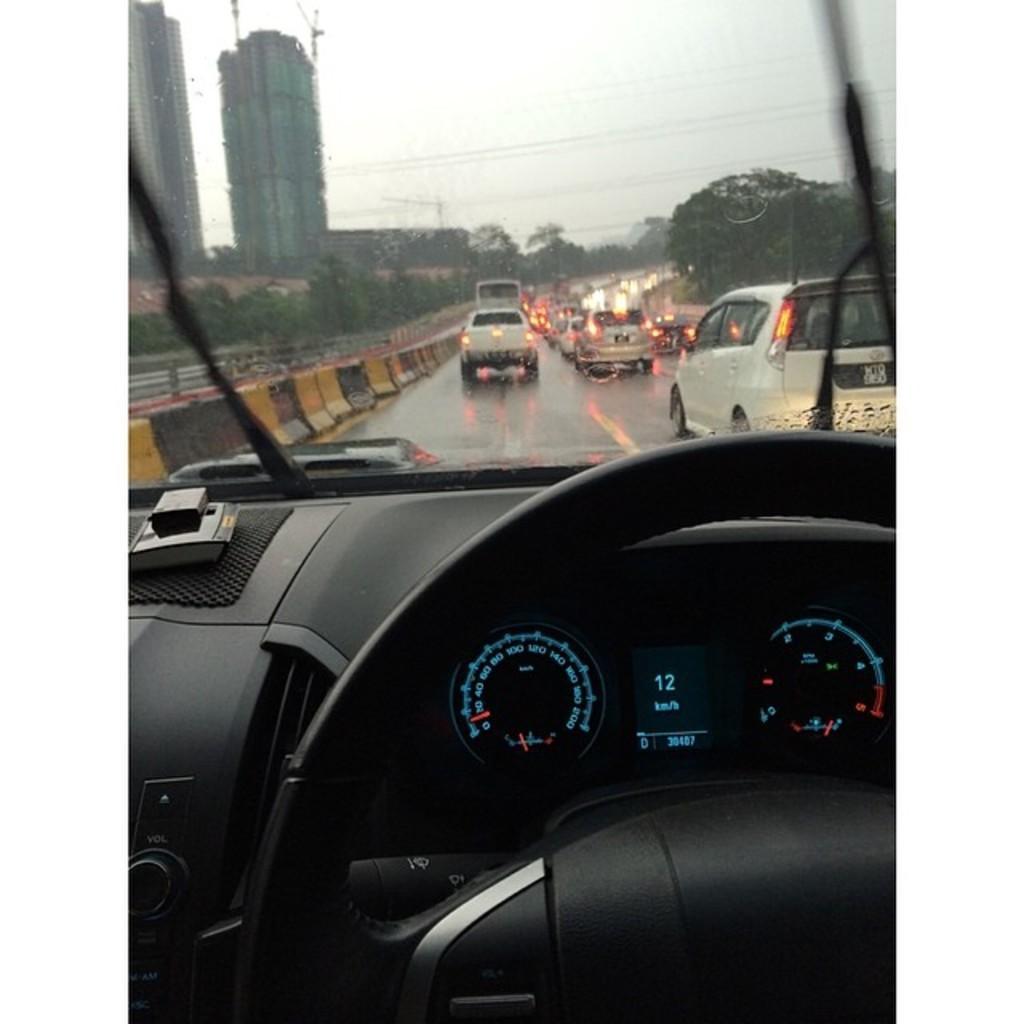Describe this image in one or two sentences. In this picture I can see the inside view of a car at the bottom of the picture. There are a few vehicles visible on the road. I can see the divider on the road. I can see a few trees and buildings in the background. Some wires are visible on top of the picture. 